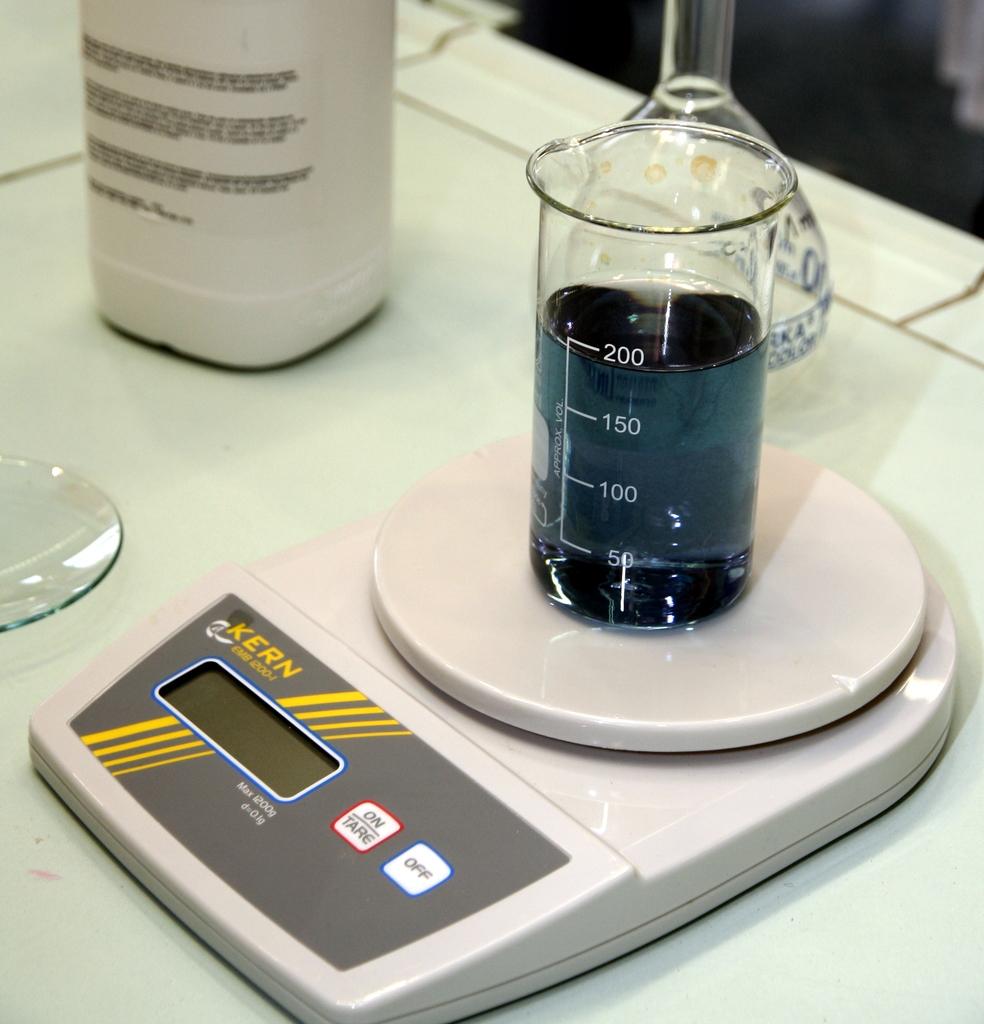Is this a scale?
Keep it short and to the point. Answering does not require reading text in the image. How much liquid is in the beaker?
Your answer should be very brief. 200. 